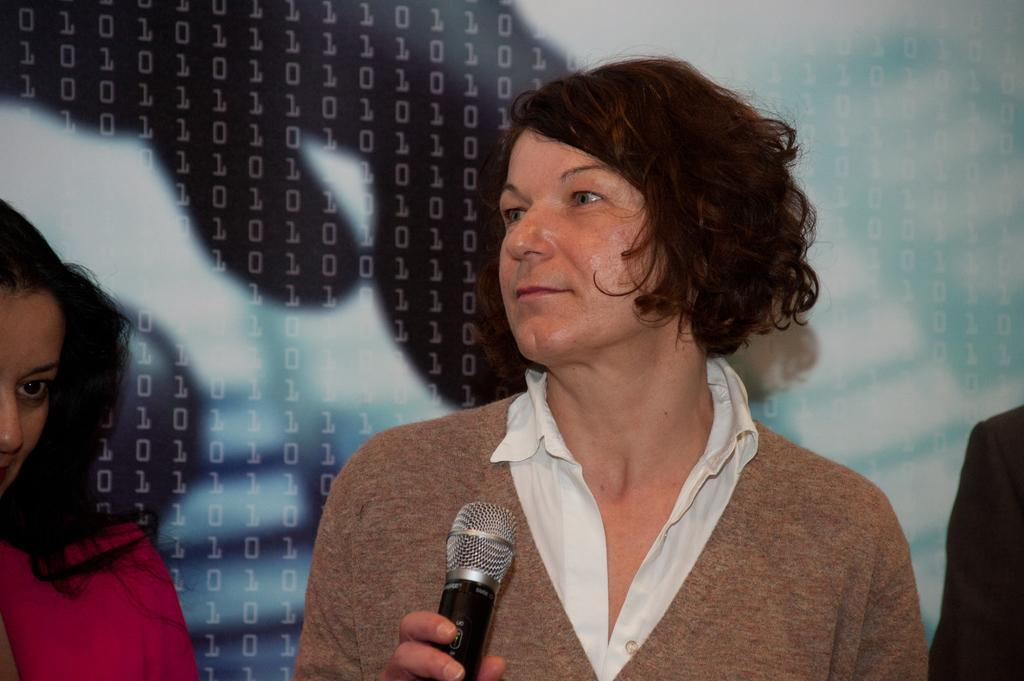What is the woman in the image holding? The woman is holding a mic in the image. Can you describe the position of the second woman in the image? The second woman is standing on the left side of the image. What can be seen in the background of the image? There is a screen in the background of the image. What type of pollution can be seen in the image? There is no pollution visible in the image. Can you describe the mark on the screen in the image? There is no mark visible on the screen in the image. 